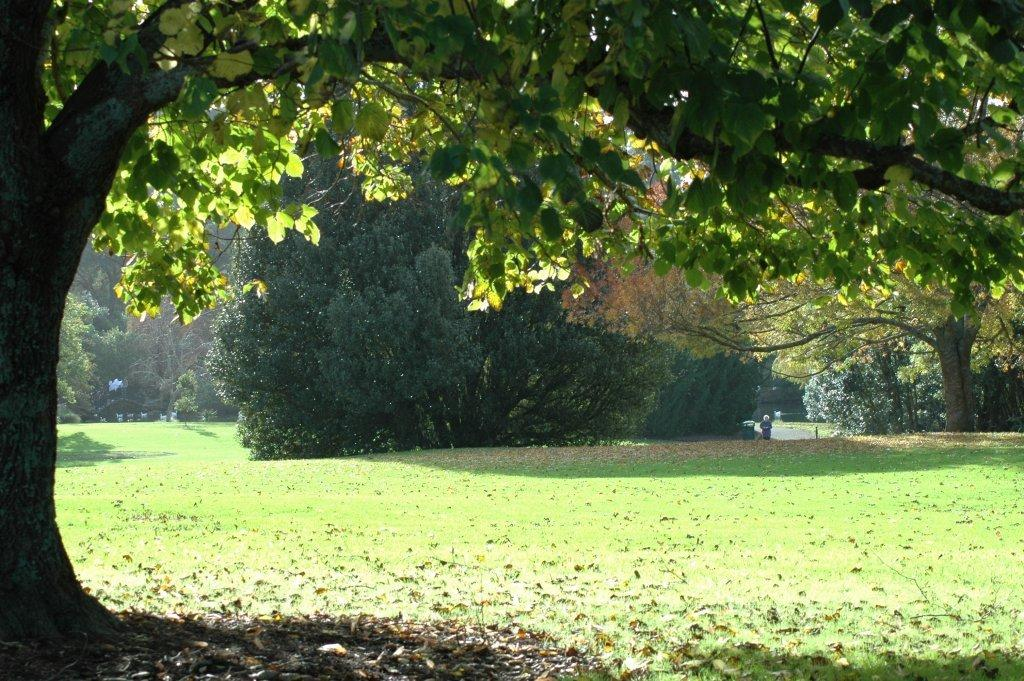What type of vegetation can be seen in the image? There is grass and dried leaves in the image. Are there any trees visible in the image? Yes, there are trees in the image. What type of knowledge can be gained from the leaf in the image? There is no leaf present in the image that can provide knowledge. How does the walk in the image contribute to the overall scene? There is no walk depicted in the image; it only features grass, dried leaves, and trees. 